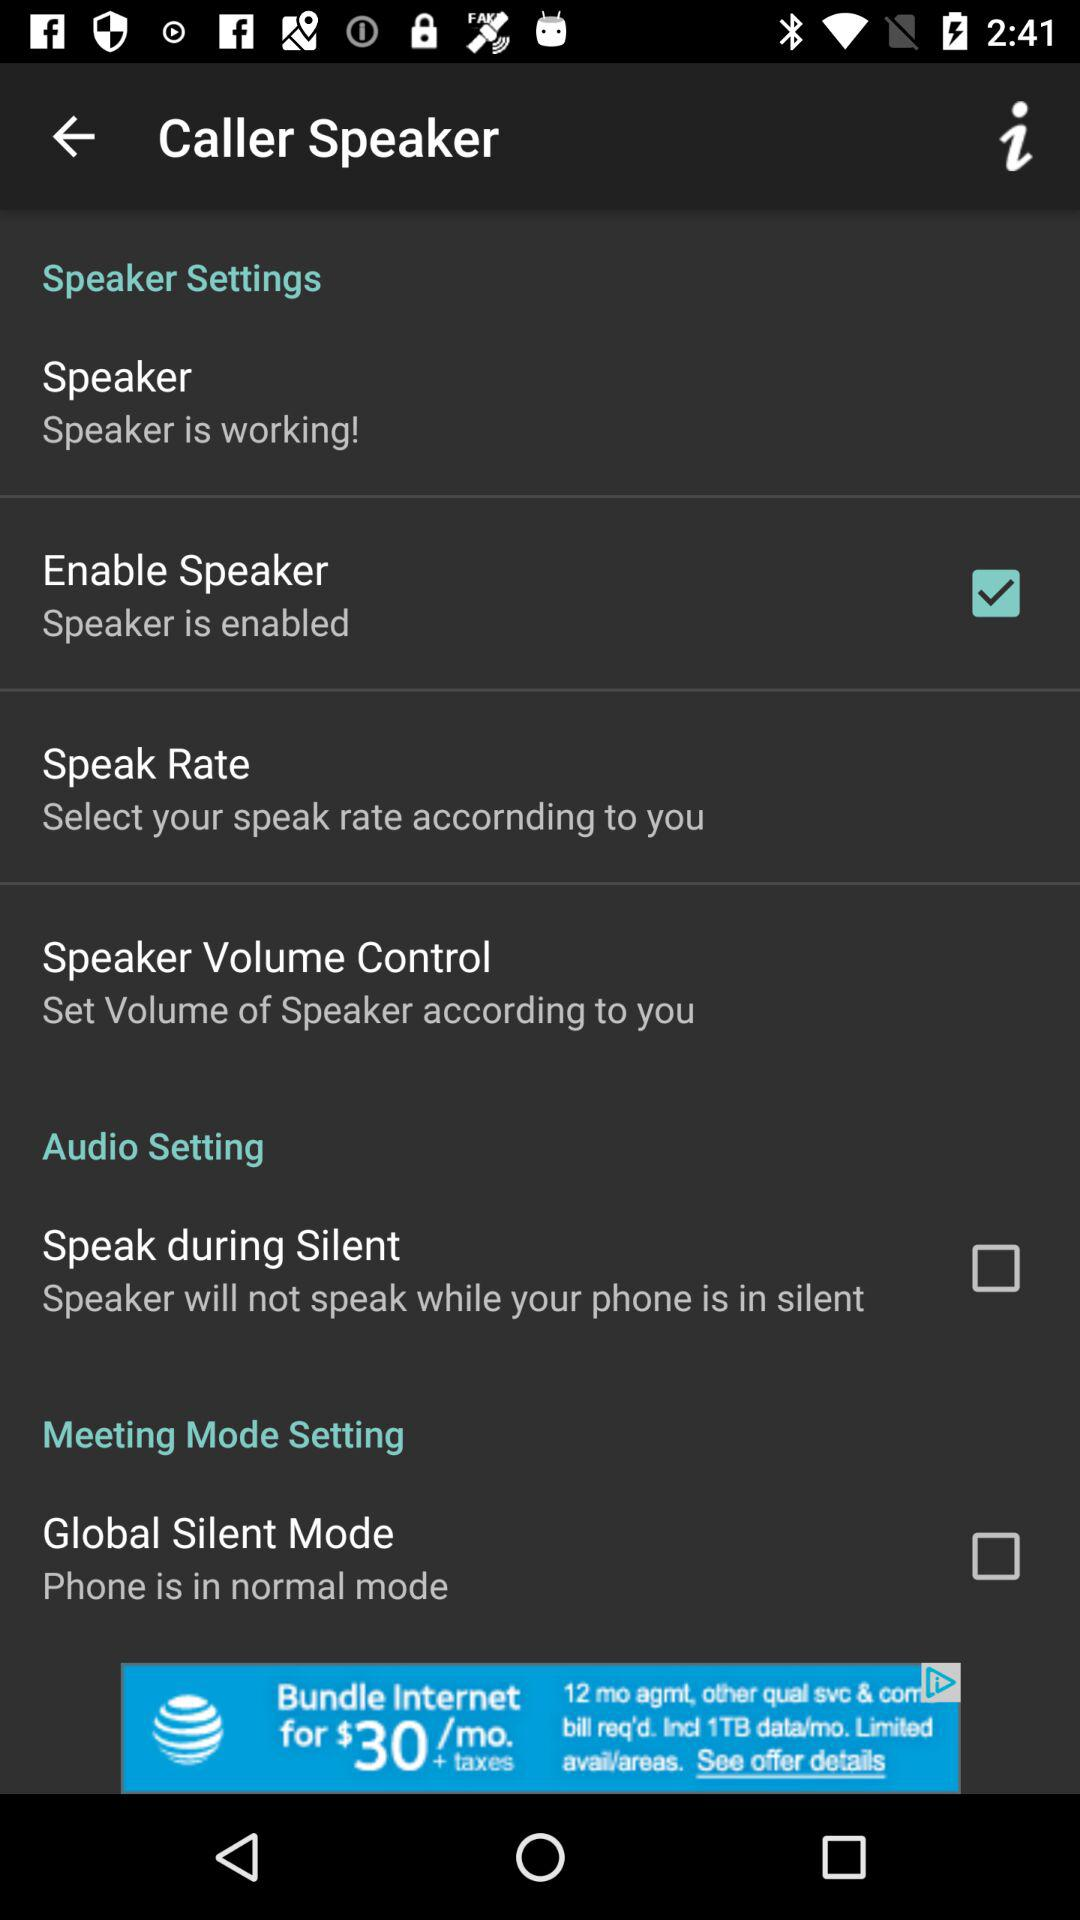How many speaker settings are there?
Answer the question using a single word or phrase. 4 